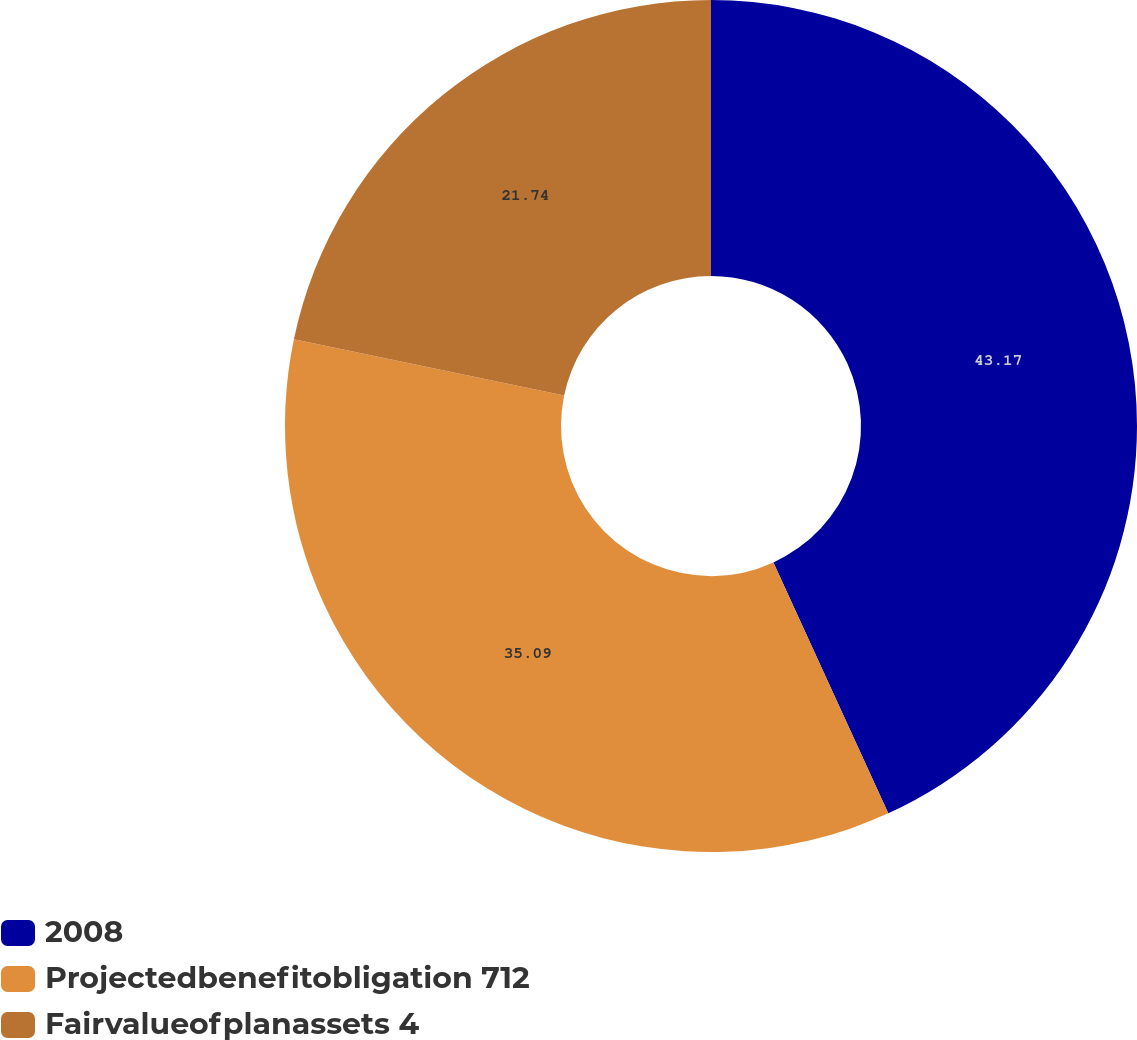Convert chart to OTSL. <chart><loc_0><loc_0><loc_500><loc_500><pie_chart><fcel>2008<fcel>Projectedbenefitobligation 712<fcel>Fairvalueofplanassets 4<nl><fcel>43.17%<fcel>35.09%<fcel>21.74%<nl></chart> 